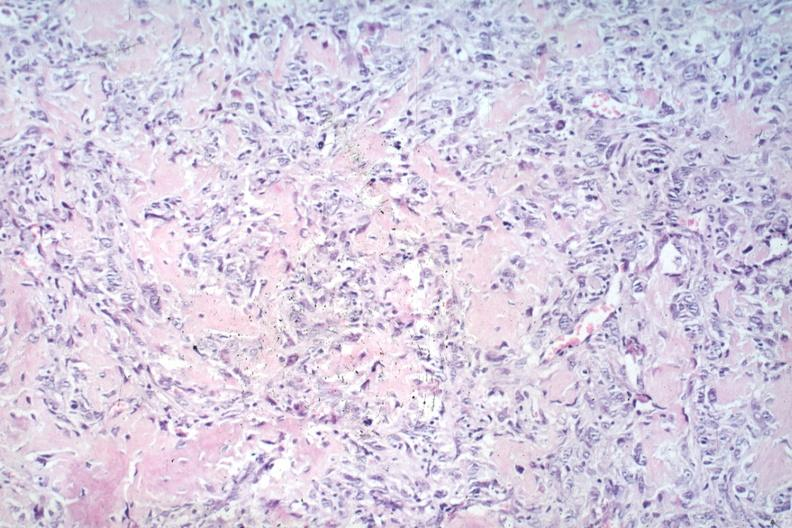what is present?
Answer the question using a single word or phrase. Joints 